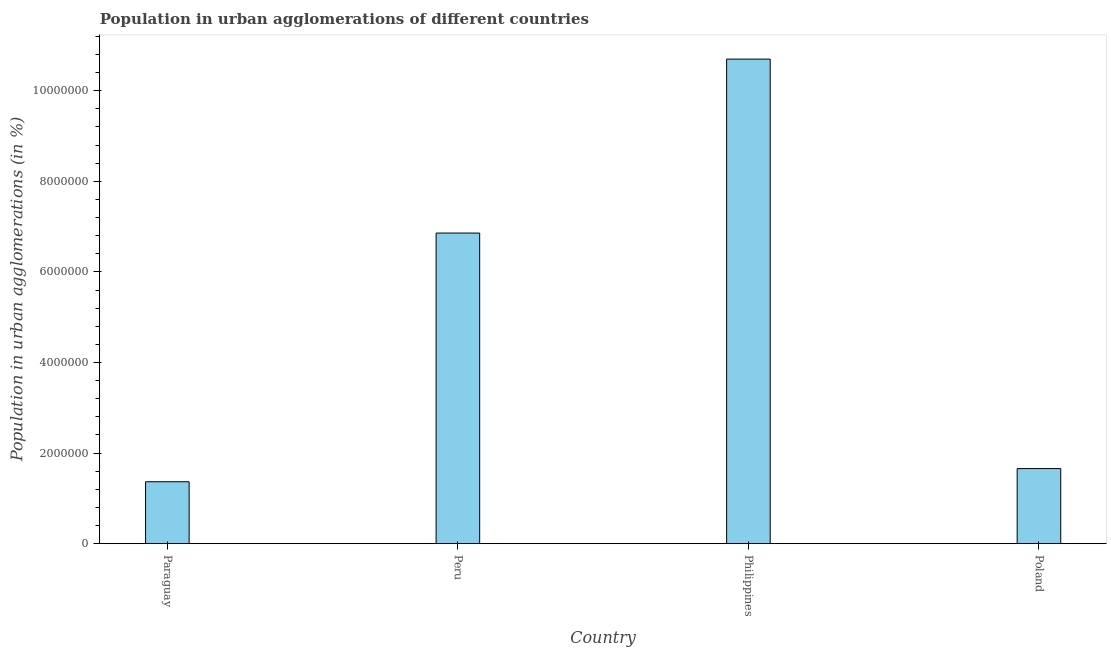Does the graph contain grids?
Your response must be concise. No. What is the title of the graph?
Make the answer very short. Population in urban agglomerations of different countries. What is the label or title of the Y-axis?
Offer a terse response. Population in urban agglomerations (in %). What is the population in urban agglomerations in Paraguay?
Provide a succinct answer. 1.37e+06. Across all countries, what is the maximum population in urban agglomerations?
Your answer should be compact. 1.07e+07. Across all countries, what is the minimum population in urban agglomerations?
Give a very brief answer. 1.37e+06. In which country was the population in urban agglomerations maximum?
Ensure brevity in your answer.  Philippines. In which country was the population in urban agglomerations minimum?
Make the answer very short. Paraguay. What is the sum of the population in urban agglomerations?
Provide a short and direct response. 2.06e+07. What is the difference between the population in urban agglomerations in Philippines and Poland?
Your answer should be compact. 9.04e+06. What is the average population in urban agglomerations per country?
Ensure brevity in your answer.  5.15e+06. What is the median population in urban agglomerations?
Make the answer very short. 4.26e+06. In how many countries, is the population in urban agglomerations greater than 8400000 %?
Give a very brief answer. 1. What is the ratio of the population in urban agglomerations in Paraguay to that in Peru?
Ensure brevity in your answer.  0.2. Is the population in urban agglomerations in Paraguay less than that in Philippines?
Provide a short and direct response. Yes. What is the difference between the highest and the second highest population in urban agglomerations?
Your answer should be very brief. 3.84e+06. Is the sum of the population in urban agglomerations in Paraguay and Philippines greater than the maximum population in urban agglomerations across all countries?
Your response must be concise. Yes. What is the difference between the highest and the lowest population in urban agglomerations?
Make the answer very short. 9.33e+06. How many bars are there?
Provide a short and direct response. 4. How many countries are there in the graph?
Ensure brevity in your answer.  4. What is the Population in urban agglomerations (in %) in Paraguay?
Provide a short and direct response. 1.37e+06. What is the Population in urban agglomerations (in %) of Peru?
Make the answer very short. 6.86e+06. What is the Population in urban agglomerations (in %) of Philippines?
Keep it short and to the point. 1.07e+07. What is the Population in urban agglomerations (in %) in Poland?
Your answer should be compact. 1.66e+06. What is the difference between the Population in urban agglomerations (in %) in Paraguay and Peru?
Make the answer very short. -5.49e+06. What is the difference between the Population in urban agglomerations (in %) in Paraguay and Philippines?
Make the answer very short. -9.33e+06. What is the difference between the Population in urban agglomerations (in %) in Paraguay and Poland?
Give a very brief answer. -2.91e+05. What is the difference between the Population in urban agglomerations (in %) in Peru and Philippines?
Your answer should be compact. -3.84e+06. What is the difference between the Population in urban agglomerations (in %) in Peru and Poland?
Offer a terse response. 5.20e+06. What is the difference between the Population in urban agglomerations (in %) in Philippines and Poland?
Your response must be concise. 9.04e+06. What is the ratio of the Population in urban agglomerations (in %) in Paraguay to that in Peru?
Offer a very short reply. 0.2. What is the ratio of the Population in urban agglomerations (in %) in Paraguay to that in Philippines?
Offer a very short reply. 0.13. What is the ratio of the Population in urban agglomerations (in %) in Paraguay to that in Poland?
Make the answer very short. 0.82. What is the ratio of the Population in urban agglomerations (in %) in Peru to that in Philippines?
Provide a succinct answer. 0.64. What is the ratio of the Population in urban agglomerations (in %) in Peru to that in Poland?
Make the answer very short. 4.14. What is the ratio of the Population in urban agglomerations (in %) in Philippines to that in Poland?
Ensure brevity in your answer.  6.46. 